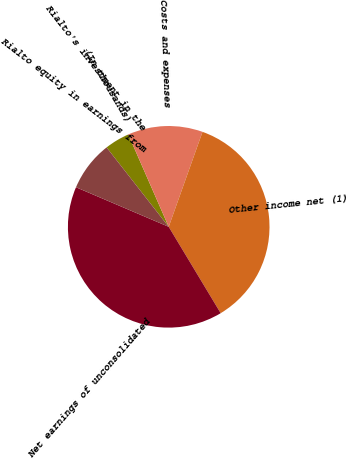<chart> <loc_0><loc_0><loc_500><loc_500><pie_chart><fcel>(In thousands)<fcel>Costs and expenses<fcel>Other income net (1)<fcel>Net earnings of unconsolidated<fcel>Rialto equity in earnings from<fcel>Rialto's investment in the<nl><fcel>4.0%<fcel>12.01%<fcel>35.93%<fcel>40.04%<fcel>8.01%<fcel>0.0%<nl></chart> 